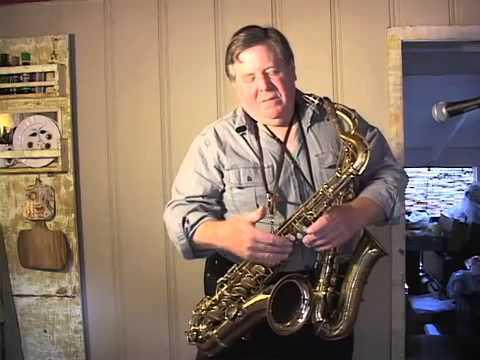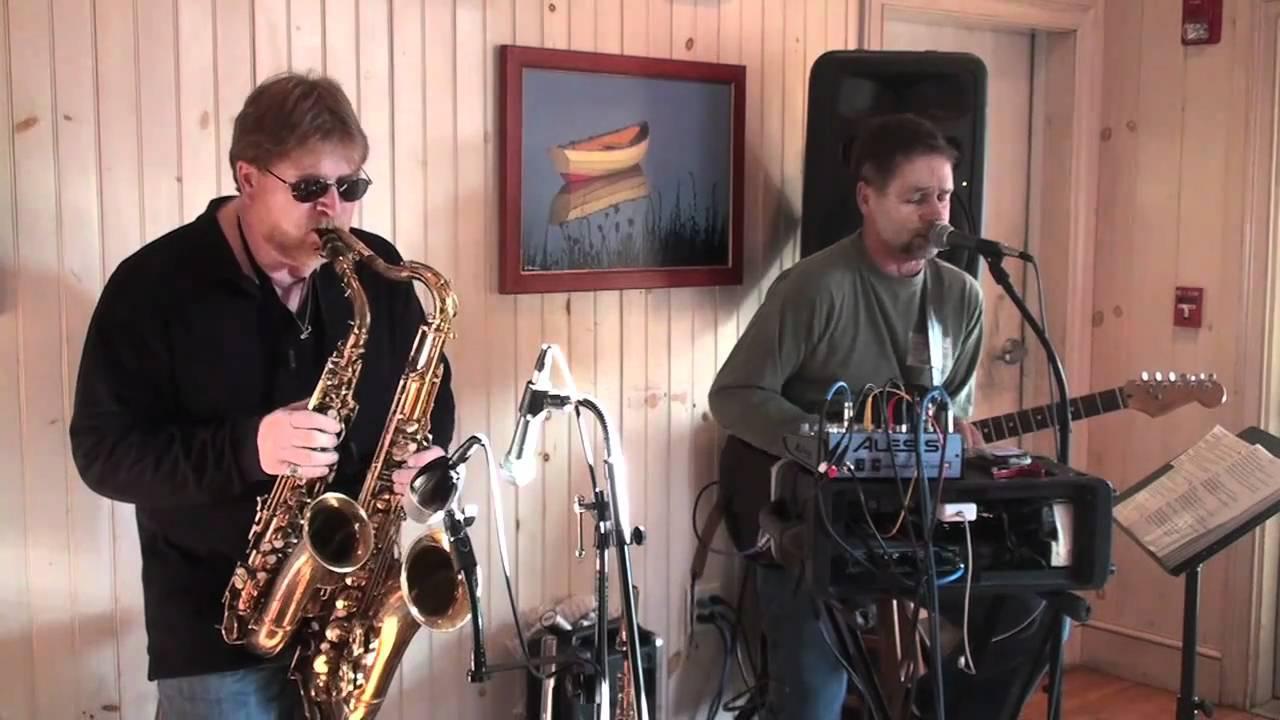The first image is the image on the left, the second image is the image on the right. Evaluate the accuracy of this statement regarding the images: "In one image, a man with a music stand near him sits and plays a guitar while another person wearing glasses is playing at least one saxophone.". Is it true? Answer yes or no. Yes. The first image is the image on the left, the second image is the image on the right. For the images shown, is this caption "A man is holding two saxophones in the image on the left." true? Answer yes or no. Yes. The first image is the image on the left, the second image is the image on the right. Examine the images to the left and right. Is the description "An image shows two men side-by-side holding instruments, and at least one of them wears a black short-sleeved t-shirt." accurate? Answer yes or no. No. The first image is the image on the left, the second image is the image on the right. Examine the images to the left and right. Is the description "there is a bald ban holding an instrument with a bracelet  on and a short sleeved button down shirt" accurate? Answer yes or no. No. 